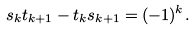Convert formula to latex. <formula><loc_0><loc_0><loc_500><loc_500>s _ { k } t _ { k + 1 } - t _ { k } s _ { k + 1 } = ( - 1 ) ^ { k } .</formula> 